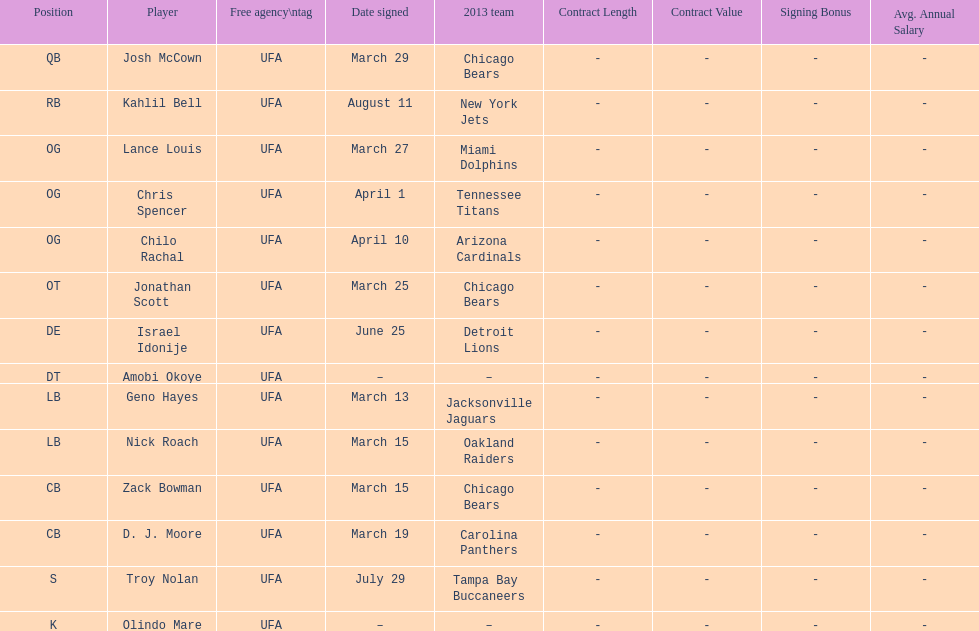Can you give me this table as a dict? {'header': ['Position', 'Player', 'Free agency\\ntag', 'Date signed', '2013 team', 'Contract Length', 'Contract Value', 'Signing Bonus', 'Avg. Annual Salary'], 'rows': [['QB', 'Josh McCown', 'UFA', 'March 29', 'Chicago Bears', '-', '-', '-', '-'], ['RB', 'Kahlil Bell', 'UFA', 'August 11', 'New York Jets', '-', '-', '-', '-'], ['OG', 'Lance Louis', 'UFA', 'March 27', 'Miami Dolphins', '-', '-', '-', '-'], ['OG', 'Chris Spencer', 'UFA', 'April 1', 'Tennessee Titans', '-', '-', '-', '-'], ['OG', 'Chilo Rachal', 'UFA', 'April 10', 'Arizona Cardinals', '-', '-', '-', '-'], ['OT', 'Jonathan Scott', 'UFA', 'March 25', 'Chicago Bears', '-', '-', '-', '-'], ['DE', 'Israel Idonije', 'UFA', 'June 25', 'Detroit Lions', '-', '-', '-', '-'], ['DT', 'Amobi Okoye', 'UFA', '–', '–', '-', '-', '-', '-'], ['LB', 'Geno Hayes', 'UFA', 'March 13', 'Jacksonville Jaguars', '-', '-', '-', '-'], ['LB', 'Nick Roach', 'UFA', 'March 15', 'Oakland Raiders', '-', '-', '-', '-'], ['CB', 'Zack Bowman', 'UFA', 'March 15', 'Chicago Bears', '-', '-', '-', '-'], ['CB', 'D. J. Moore', 'UFA', 'March 19', 'Carolina Panthers', '-', '-', '-', '-'], ['S', 'Troy Nolan', 'UFA', 'July 29', 'Tampa Bay Buccaneers', '-', '-', '-', '-'], ['K', 'Olindo Mare', 'UFA', '–', '–', '-', '-', '-', '-']]} Total count of players who registered in march? 7. 